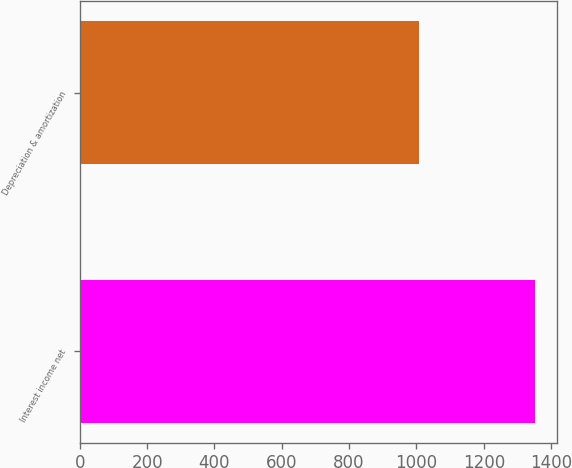Convert chart. <chart><loc_0><loc_0><loc_500><loc_500><bar_chart><fcel>Interest income net<fcel>Depreciation & amortization<nl><fcel>1351<fcel>1009<nl></chart> 